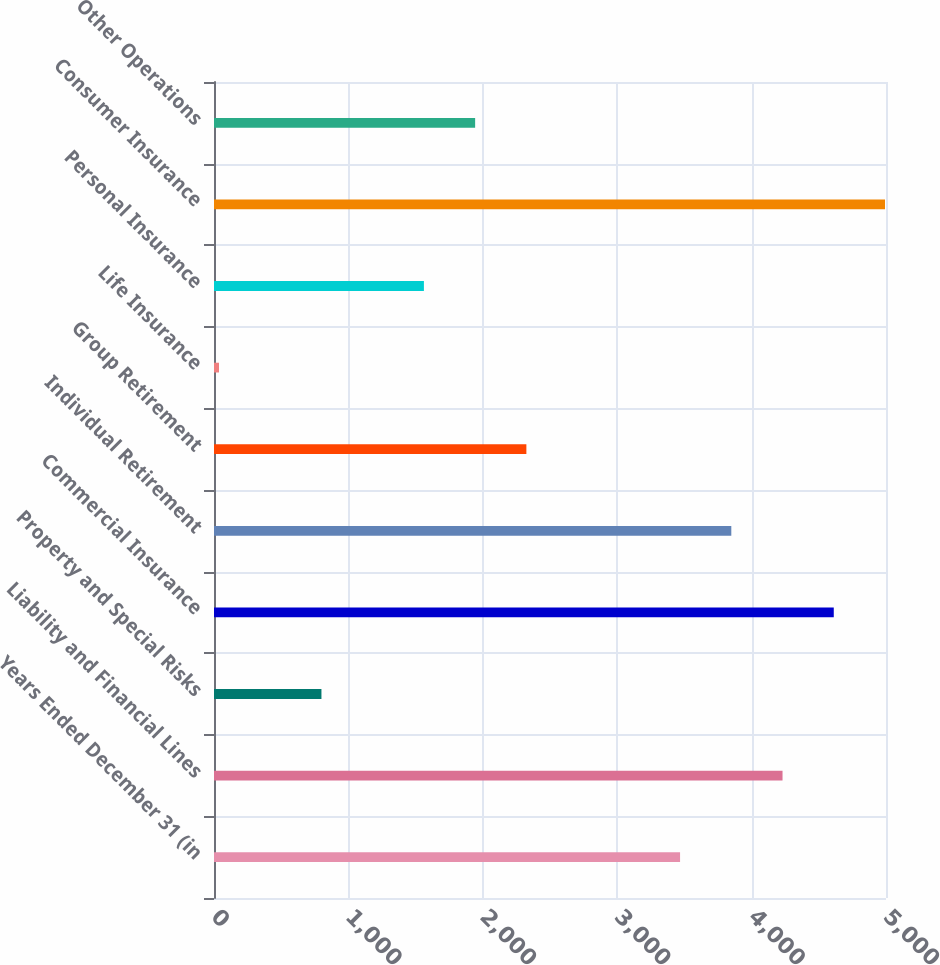Convert chart to OTSL. <chart><loc_0><loc_0><loc_500><loc_500><bar_chart><fcel>Years Ended December 31 (in<fcel>Liability and Financial Lines<fcel>Property and Special Risks<fcel>Commercial Insurance<fcel>Individual Retirement<fcel>Group Retirement<fcel>Life Insurance<fcel>Personal Insurance<fcel>Consumer Insurance<fcel>Other Operations<nl><fcel>3467.8<fcel>4230.2<fcel>799.4<fcel>4611.4<fcel>3849<fcel>2324.2<fcel>37<fcel>1561.8<fcel>4992.6<fcel>1943<nl></chart> 